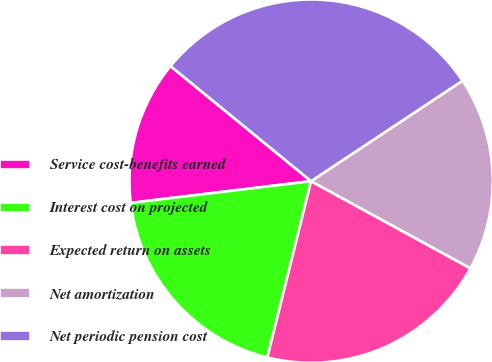Convert chart to OTSL. <chart><loc_0><loc_0><loc_500><loc_500><pie_chart><fcel>Service cost-benefits earned<fcel>Interest cost on projected<fcel>Expected return on assets<fcel>Net amortization<fcel>Net periodic pension cost<nl><fcel>12.83%<fcel>19.22%<fcel>20.91%<fcel>17.29%<fcel>29.76%<nl></chart> 